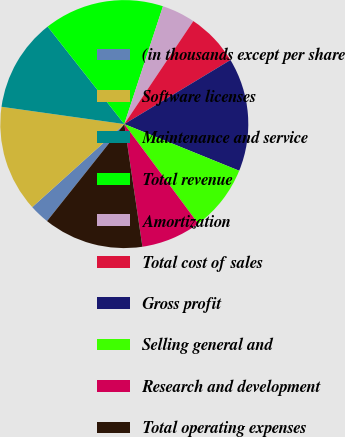<chart> <loc_0><loc_0><loc_500><loc_500><pie_chart><fcel>(in thousands except per share<fcel>Software licenses<fcel>Maintenance and service<fcel>Total revenue<fcel>Amortization<fcel>Total cost of sales<fcel>Gross profit<fcel>Selling general and<fcel>Research and development<fcel>Total operating expenses<nl><fcel>2.61%<fcel>13.91%<fcel>12.17%<fcel>15.65%<fcel>4.35%<fcel>6.96%<fcel>14.78%<fcel>8.7%<fcel>7.83%<fcel>13.04%<nl></chart> 